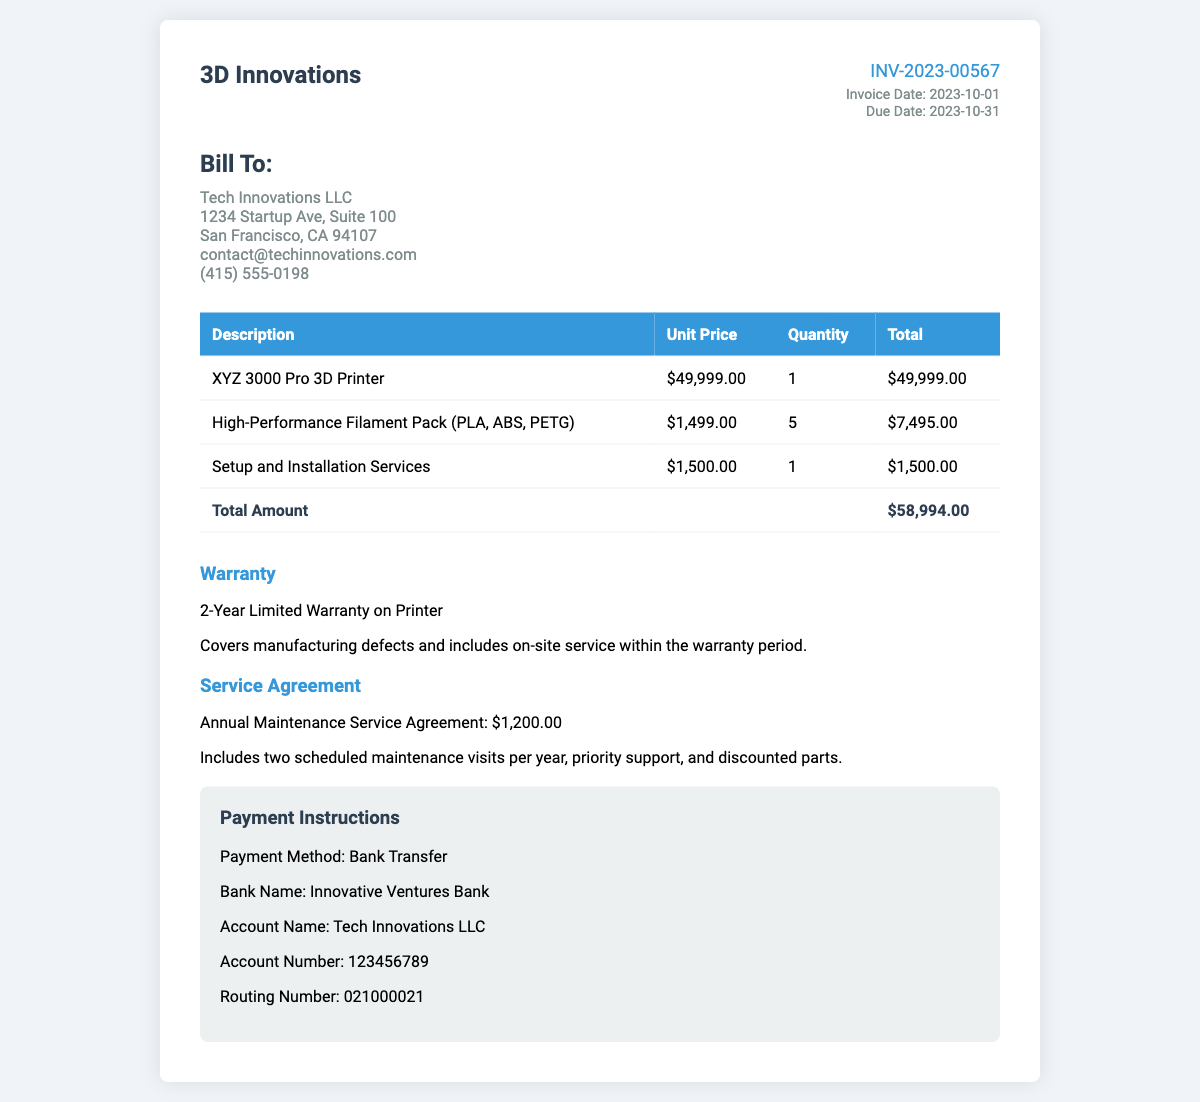What is the total amount of the invoice? The total amount is found in the table under "Total Amount," which sums up the costs of the items listed.
Answer: $58,994.00 What is the invoice date? The invoice date is specified in the invoice details section, indicating when the invoice was issued.
Answer: 2023-10-01 What is included in the warranty? The warranty section describes what is covered under the warranty for the 3D printer.
Answer: 2-Year Limited Warranty on Printer How many high-performance filament packs were purchased? The quantity of filament packs is noted in the itemized cost table under the respective item.
Answer: 5 What is the cost of the Service Agreement? The cost of the Service Agreement is specified in the service agreement section of the invoice.
Answer: $1,200.00 Who is the bill recipient? The bill recipient information is identified at the beginning of the document under the "Bill To" section.
Answer: Tech Innovations LLC What is the setup and installation service cost? The cost of setup and installation services is listed in the itemized table under the respective service.
Answer: $1,500.00 What is the due date for the invoice? The due date is indicated in the invoice details section, showing when payment is expected.
Answer: 2023-10-31 Which bank is used for payment? The bank name is provided in the payment instructions section as the financial institution for the transaction.
Answer: Innovative Ventures Bank 